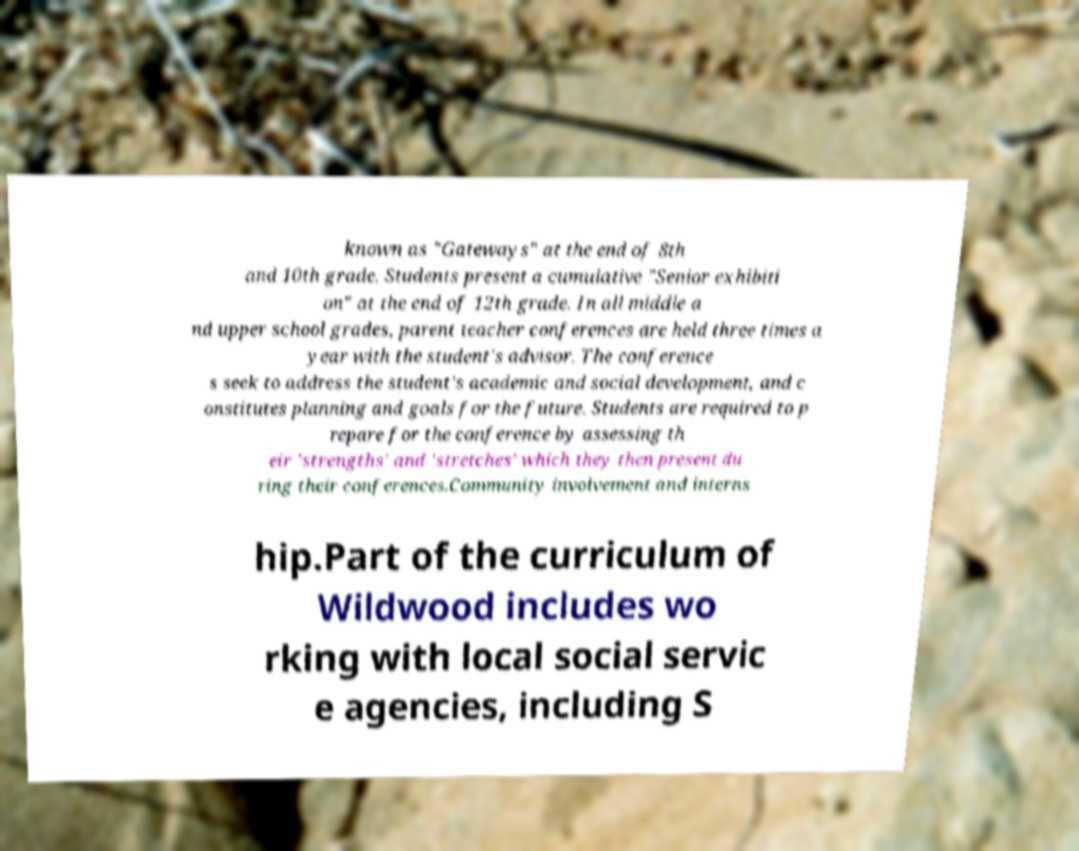Please identify and transcribe the text found in this image. known as "Gateways" at the end of 8th and 10th grade. Students present a cumulative "Senior exhibiti on" at the end of 12th grade. In all middle a nd upper school grades, parent teacher conferences are held three times a year with the student's advisor. The conference s seek to address the student's academic and social development, and c onstitutes planning and goals for the future. Students are required to p repare for the conference by assessing th eir 'strengths' and 'stretches' which they then present du ring their conferences.Community involvement and interns hip.Part of the curriculum of Wildwood includes wo rking with local social servic e agencies, including S 